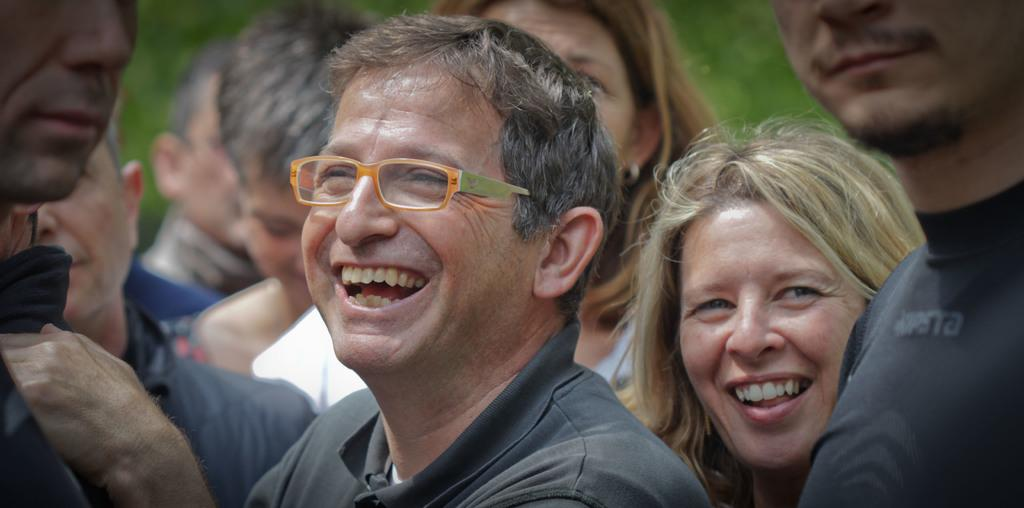Who is the main subject in the image? There is a man in the center of the image. What can be observed about the man's appearance? The man is wearing spectacles. Are there any other people in the image? Yes, there is a group of people around the man. What type of goat can be seen grazing in the yard in the image? There is no goat or yard present in the image; it features a man wearing spectacles with a group of people around him. 